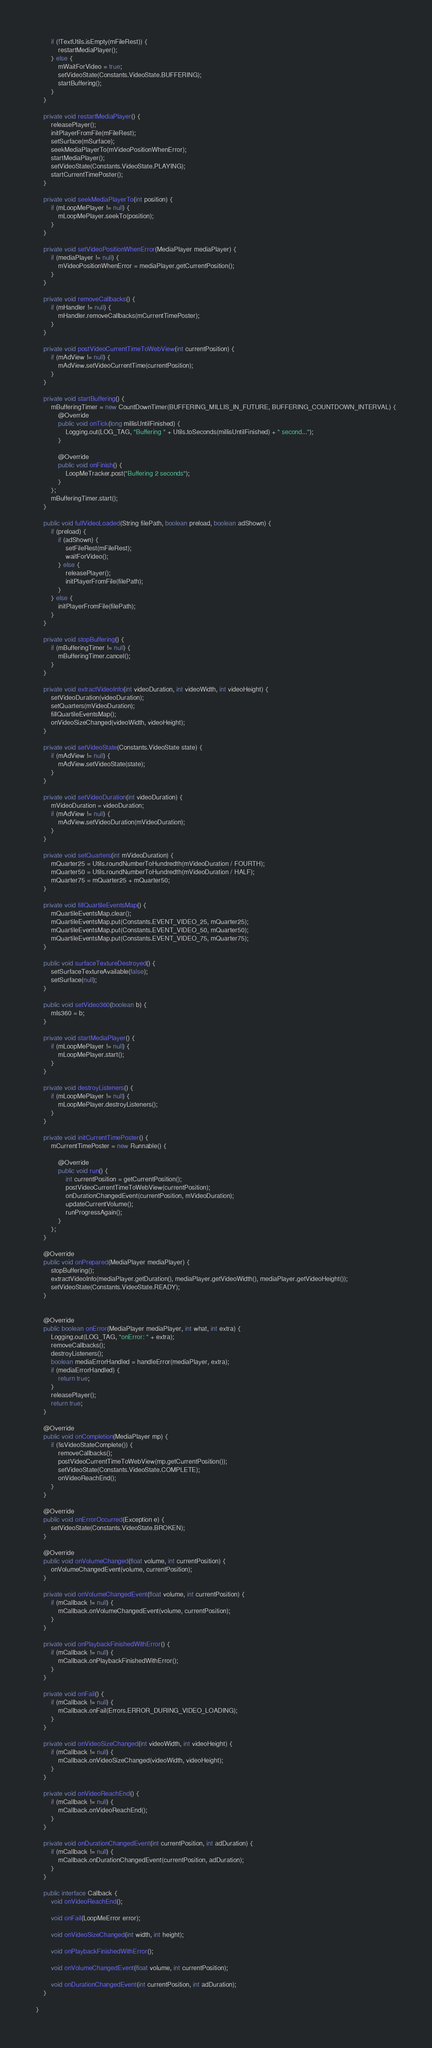Convert code to text. <code><loc_0><loc_0><loc_500><loc_500><_Java_>        if (!TextUtils.isEmpty(mFileRest)) {
            restartMediaPlayer();
        } else {
            mWaitForVideo = true;
            setVideoState(Constants.VideoState.BUFFERING);
            startBuffering();
        }
    }

    private void restartMediaPlayer() {
        releasePlayer();
        initPlayerFromFile(mFileRest);
        setSurface(mSurface);
        seekMediaPlayerTo(mVideoPositionWhenError);
        startMediaPlayer();
        setVideoState(Constants.VideoState.PLAYING);
        startCurrentTimePoster();
    }

    private void seekMediaPlayerTo(int position) {
        if (mLoopMePlayer != null) {
            mLoopMePlayer.seekTo(position);
        }
    }

    private void setVideoPositionWhenError(MediaPlayer mediaPlayer) {
        if (mediaPlayer != null) {
            mVideoPositionWhenError = mediaPlayer.getCurrentPosition();
        }
    }

    private void removeCallbacks() {
        if (mHandler != null) {
            mHandler.removeCallbacks(mCurrentTimePoster);
        }
    }

    private void postVideoCurrentTimeToWebView(int currentPosition) {
        if (mAdView != null) {
            mAdView.setVideoCurrentTime(currentPosition);
        }
    }

    private void startBuffering() {
        mBufferingTimer = new CountDownTimer(BUFFERING_MILLIS_IN_FUTURE, BUFFERING_COUNTDOWN_INTERVAL) {
            @Override
            public void onTick(long millisUntilFinished) {
                Logging.out(LOG_TAG, "Buffering " + Utils.toSeconds(millisUntilFinished) + " second...");
            }

            @Override
            public void onFinish() {
                LoopMeTracker.post("Buffering 2 seconds");
            }
        };
        mBufferingTimer.start();
    }

    public void fullVideoLoaded(String filePath, boolean preload, boolean adShown) {
        if (preload) {
            if (adShown) {
                setFileRest(mFileRest);
                waitForVideo();
            } else {
                releasePlayer();
                initPlayerFromFile(filePath);
            }
        } else {
            initPlayerFromFile(filePath);
        }
    }

    private void stopBuffering() {
        if (mBufferingTimer != null) {
            mBufferingTimer.cancel();
        }
    }

    private void extractVideoInfo(int videoDuration, int videoWidth, int videoHeight) {
        setVideoDuration(videoDuration);
        setQuarters(mVideoDuration);
        fillQuartileEventsMap();
        onVideoSizeChanged(videoWidth, videoHeight);
    }

    private void setVideoState(Constants.VideoState state) {
        if (mAdView != null) {
            mAdView.setVideoState(state);
        }
    }

    private void setVideoDuration(int videoDuration) {
        mVideoDuration = videoDuration;
        if (mAdView != null) {
            mAdView.setVideoDuration(mVideoDuration);
        }
    }

    private void setQuarters(int mVideoDuration) {
        mQuarter25 = Utils.roundNumberToHundredth(mVideoDuration / FOURTH);
        mQuarter50 = Utils.roundNumberToHundredth(mVideoDuration / HALF);
        mQuarter75 = mQuarter25 + mQuarter50;
    }

    private void fillQuartileEventsMap() {
        mQuartileEventsMap.clear();
        mQuartileEventsMap.put(Constants.EVENT_VIDEO_25, mQuarter25);
        mQuartileEventsMap.put(Constants.EVENT_VIDEO_50, mQuarter50);
        mQuartileEventsMap.put(Constants.EVENT_VIDEO_75, mQuarter75);
    }

    public void surfaceTextureDestroyed() {
        setSurfaceTextureAvailable(false);
        setSurface(null);
    }

    public void setVideo360(boolean b) {
        mIs360 = b;
    }

    private void startMediaPlayer() {
        if (mLoopMePlayer != null) {
            mLoopMePlayer.start();
        }
    }

    private void destroyListeners() {
        if (mLoopMePlayer != null) {
            mLoopMePlayer.destroyListeners();
        }
    }

    private void initCurrentTimePoster() {
        mCurrentTimePoster = new Runnable() {

            @Override
            public void run() {
                int currentPosition = getCurrentPosition();
                postVideoCurrentTimeToWebView(currentPosition);
                onDurationChangedEvent(currentPosition, mVideoDuration);
                updateCurrentVolume();
                runProgressAgain();
            }
        };
    }

    @Override
    public void onPrepared(MediaPlayer mediaPlayer) {
        stopBuffering();
        extractVideoInfo(mediaPlayer.getDuration(), mediaPlayer.getVideoWidth(), mediaPlayer.getVideoHeight());
        setVideoState(Constants.VideoState.READY);
    }


    @Override
    public boolean onError(MediaPlayer mediaPlayer, int what, int extra) {
        Logging.out(LOG_TAG, "onError: " + extra);
        removeCallbacks();
        destroyListeners();
        boolean mediaErrorHandled = handleError(mediaPlayer, extra);
        if (mediaErrorHandled) {
            return true;
        }
        releasePlayer();
        return true;
    }

    @Override
    public void onCompletion(MediaPlayer mp) {
        if (!isVideoStateComplete()) {
            removeCallbacks();
            postVideoCurrentTimeToWebView(mp.getCurrentPosition());
            setVideoState(Constants.VideoState.COMPLETE);
            onVideoReachEnd();
        }
    }

    @Override
    public void onErrorOccurred(Exception e) {
        setVideoState(Constants.VideoState.BROKEN);
    }

    @Override
    public void onVolumeChanged(float volume, int currentPosition) {
        onVolumeChangedEvent(volume, currentPosition);
    }

    private void onVolumeChangedEvent(float volume, int currentPosition) {
        if (mCallback != null) {
            mCallback.onVolumeChangedEvent(volume, currentPosition);
        }
    }

    private void onPlaybackFinishedWithError() {
        if (mCallback != null) {
            mCallback.onPlaybackFinishedWithError();
        }
    }

    private void onFail() {
        if (mCallback != null) {
            mCallback.onFail(Errors.ERROR_DURING_VIDEO_LOADING);
        }
    }

    private void onVideoSizeChanged(int videoWidth, int videoHeight) {
        if (mCallback != null) {
            mCallback.onVideoSizeChanged(videoWidth, videoHeight);
        }
    }

    private void onVideoReachEnd() {
        if (mCallback != null) {
            mCallback.onVideoReachEnd();
        }
    }

    private void onDurationChangedEvent(int currentPosition, int adDuration) {
        if (mCallback != null) {
            mCallback.onDurationChangedEvent(currentPosition, adDuration);
        }
    }

    public interface Callback {
        void onVideoReachEnd();

        void onFail(LoopMeError error);

        void onVideoSizeChanged(int width, int height);

        void onPlaybackFinishedWithError();

        void onVolumeChangedEvent(float volume, int currentPosition);

        void onDurationChangedEvent(int currentPosition, int adDuration);
    }

}</code> 